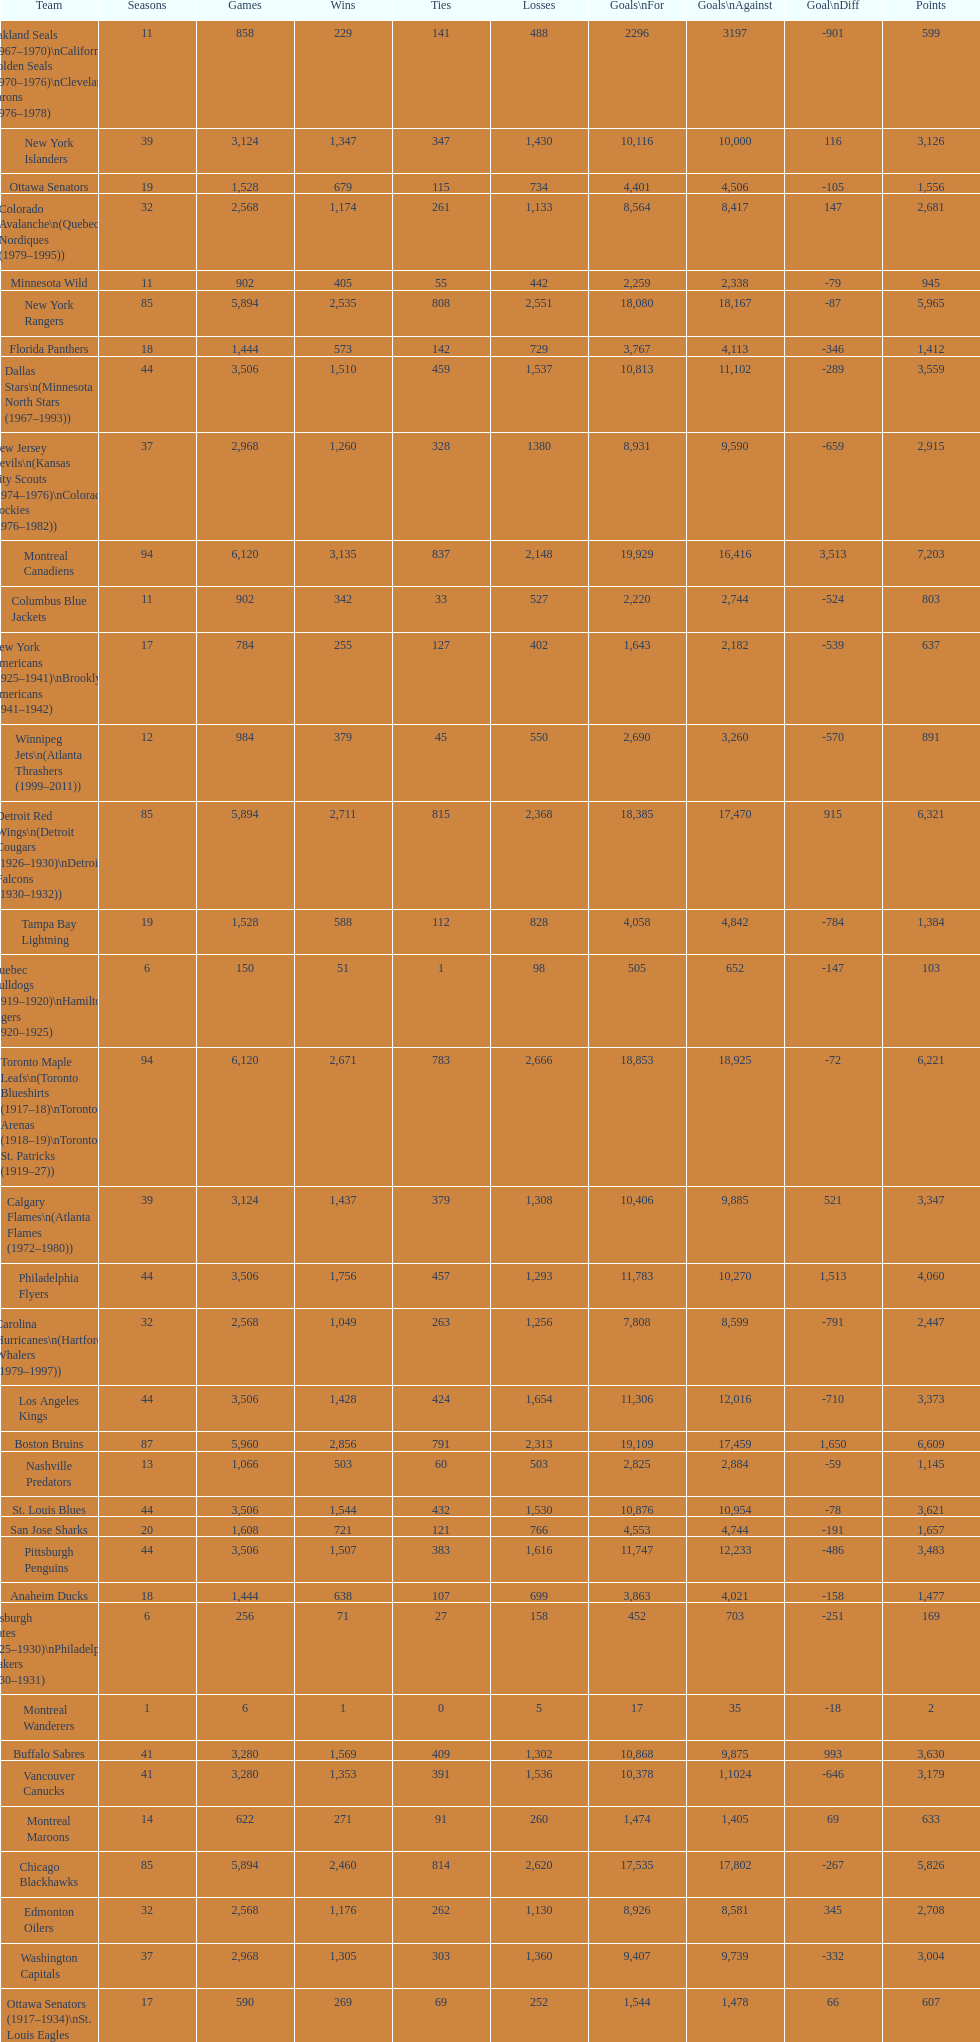Who is at the pinnacle of the list? Montreal Canadiens. 